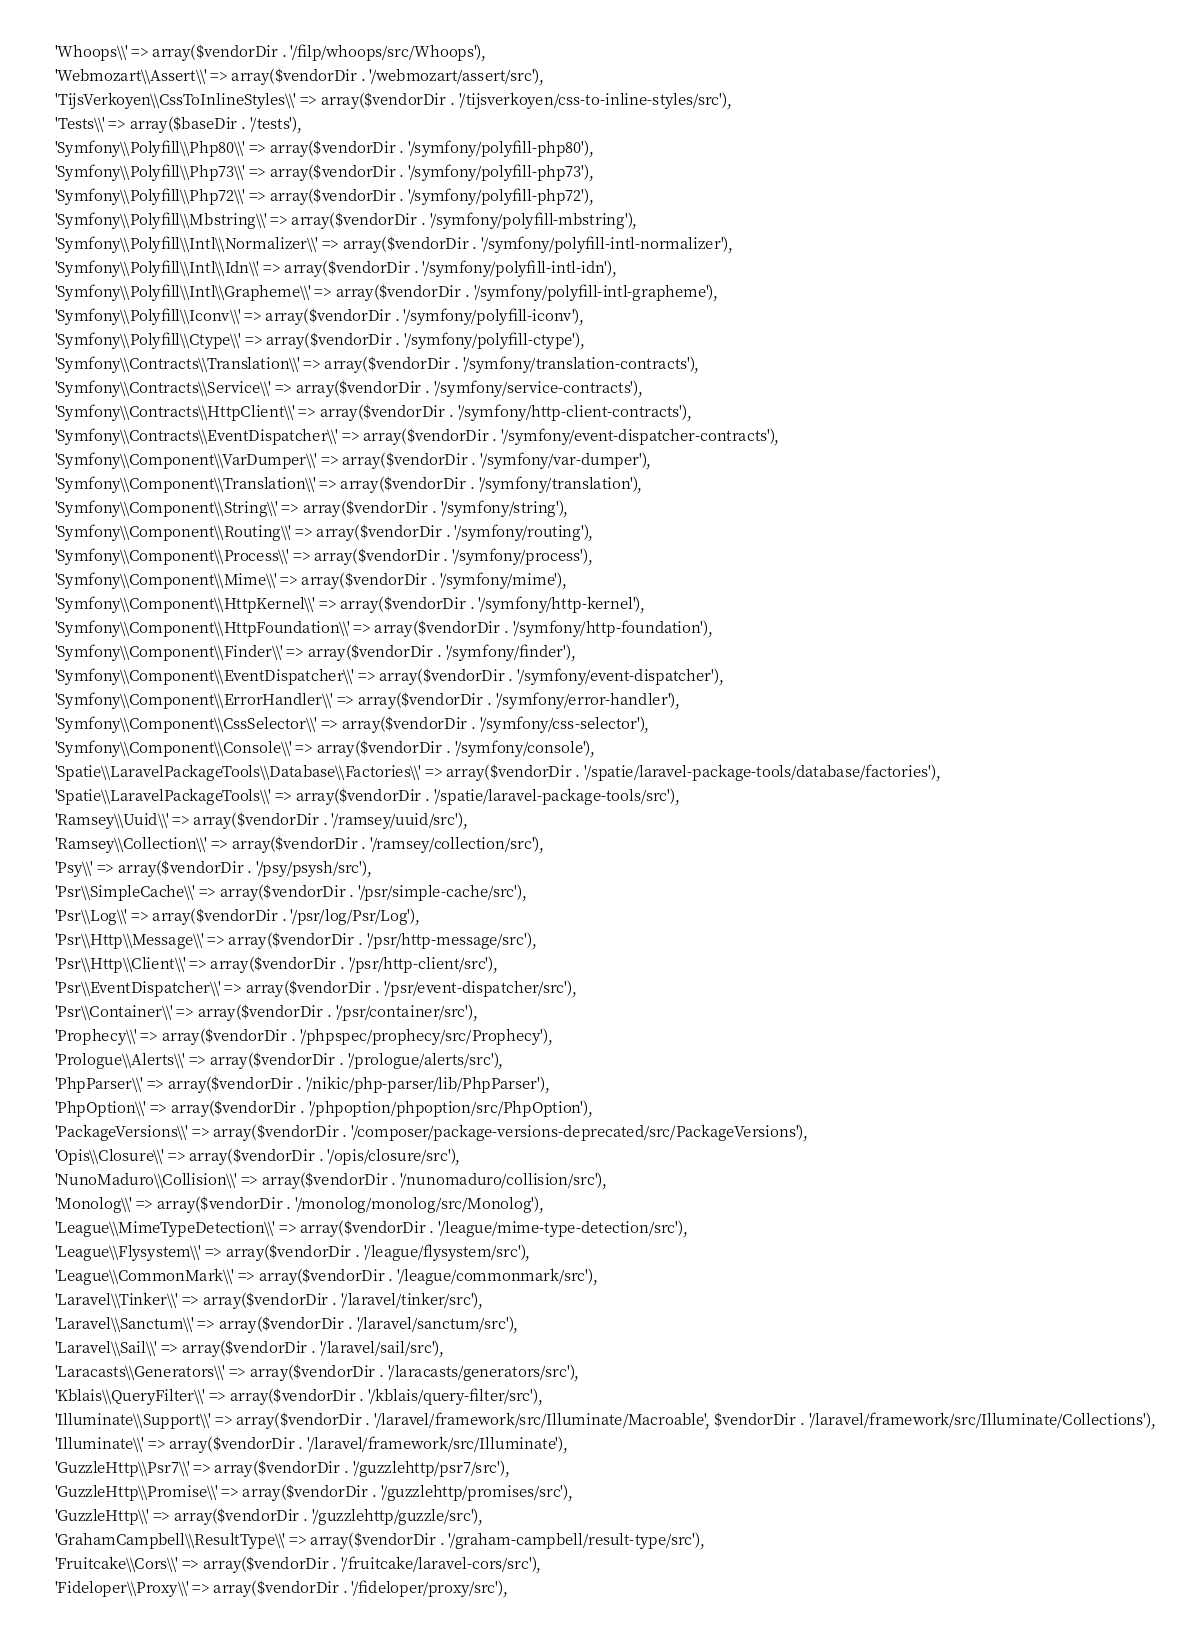<code> <loc_0><loc_0><loc_500><loc_500><_PHP_>    'Whoops\\' => array($vendorDir . '/filp/whoops/src/Whoops'),
    'Webmozart\\Assert\\' => array($vendorDir . '/webmozart/assert/src'),
    'TijsVerkoyen\\CssToInlineStyles\\' => array($vendorDir . '/tijsverkoyen/css-to-inline-styles/src'),
    'Tests\\' => array($baseDir . '/tests'),
    'Symfony\\Polyfill\\Php80\\' => array($vendorDir . '/symfony/polyfill-php80'),
    'Symfony\\Polyfill\\Php73\\' => array($vendorDir . '/symfony/polyfill-php73'),
    'Symfony\\Polyfill\\Php72\\' => array($vendorDir . '/symfony/polyfill-php72'),
    'Symfony\\Polyfill\\Mbstring\\' => array($vendorDir . '/symfony/polyfill-mbstring'),
    'Symfony\\Polyfill\\Intl\\Normalizer\\' => array($vendorDir . '/symfony/polyfill-intl-normalizer'),
    'Symfony\\Polyfill\\Intl\\Idn\\' => array($vendorDir . '/symfony/polyfill-intl-idn'),
    'Symfony\\Polyfill\\Intl\\Grapheme\\' => array($vendorDir . '/symfony/polyfill-intl-grapheme'),
    'Symfony\\Polyfill\\Iconv\\' => array($vendorDir . '/symfony/polyfill-iconv'),
    'Symfony\\Polyfill\\Ctype\\' => array($vendorDir . '/symfony/polyfill-ctype'),
    'Symfony\\Contracts\\Translation\\' => array($vendorDir . '/symfony/translation-contracts'),
    'Symfony\\Contracts\\Service\\' => array($vendorDir . '/symfony/service-contracts'),
    'Symfony\\Contracts\\HttpClient\\' => array($vendorDir . '/symfony/http-client-contracts'),
    'Symfony\\Contracts\\EventDispatcher\\' => array($vendorDir . '/symfony/event-dispatcher-contracts'),
    'Symfony\\Component\\VarDumper\\' => array($vendorDir . '/symfony/var-dumper'),
    'Symfony\\Component\\Translation\\' => array($vendorDir . '/symfony/translation'),
    'Symfony\\Component\\String\\' => array($vendorDir . '/symfony/string'),
    'Symfony\\Component\\Routing\\' => array($vendorDir . '/symfony/routing'),
    'Symfony\\Component\\Process\\' => array($vendorDir . '/symfony/process'),
    'Symfony\\Component\\Mime\\' => array($vendorDir . '/symfony/mime'),
    'Symfony\\Component\\HttpKernel\\' => array($vendorDir . '/symfony/http-kernel'),
    'Symfony\\Component\\HttpFoundation\\' => array($vendorDir . '/symfony/http-foundation'),
    'Symfony\\Component\\Finder\\' => array($vendorDir . '/symfony/finder'),
    'Symfony\\Component\\EventDispatcher\\' => array($vendorDir . '/symfony/event-dispatcher'),
    'Symfony\\Component\\ErrorHandler\\' => array($vendorDir . '/symfony/error-handler'),
    'Symfony\\Component\\CssSelector\\' => array($vendorDir . '/symfony/css-selector'),
    'Symfony\\Component\\Console\\' => array($vendorDir . '/symfony/console'),
    'Spatie\\LaravelPackageTools\\Database\\Factories\\' => array($vendorDir . '/spatie/laravel-package-tools/database/factories'),
    'Spatie\\LaravelPackageTools\\' => array($vendorDir . '/spatie/laravel-package-tools/src'),
    'Ramsey\\Uuid\\' => array($vendorDir . '/ramsey/uuid/src'),
    'Ramsey\\Collection\\' => array($vendorDir . '/ramsey/collection/src'),
    'Psy\\' => array($vendorDir . '/psy/psysh/src'),
    'Psr\\SimpleCache\\' => array($vendorDir . '/psr/simple-cache/src'),
    'Psr\\Log\\' => array($vendorDir . '/psr/log/Psr/Log'),
    'Psr\\Http\\Message\\' => array($vendorDir . '/psr/http-message/src'),
    'Psr\\Http\\Client\\' => array($vendorDir . '/psr/http-client/src'),
    'Psr\\EventDispatcher\\' => array($vendorDir . '/psr/event-dispatcher/src'),
    'Psr\\Container\\' => array($vendorDir . '/psr/container/src'),
    'Prophecy\\' => array($vendorDir . '/phpspec/prophecy/src/Prophecy'),
    'Prologue\\Alerts\\' => array($vendorDir . '/prologue/alerts/src'),
    'PhpParser\\' => array($vendorDir . '/nikic/php-parser/lib/PhpParser'),
    'PhpOption\\' => array($vendorDir . '/phpoption/phpoption/src/PhpOption'),
    'PackageVersions\\' => array($vendorDir . '/composer/package-versions-deprecated/src/PackageVersions'),
    'Opis\\Closure\\' => array($vendorDir . '/opis/closure/src'),
    'NunoMaduro\\Collision\\' => array($vendorDir . '/nunomaduro/collision/src'),
    'Monolog\\' => array($vendorDir . '/monolog/monolog/src/Monolog'),
    'League\\MimeTypeDetection\\' => array($vendorDir . '/league/mime-type-detection/src'),
    'League\\Flysystem\\' => array($vendorDir . '/league/flysystem/src'),
    'League\\CommonMark\\' => array($vendorDir . '/league/commonmark/src'),
    'Laravel\\Tinker\\' => array($vendorDir . '/laravel/tinker/src'),
    'Laravel\\Sanctum\\' => array($vendorDir . '/laravel/sanctum/src'),
    'Laravel\\Sail\\' => array($vendorDir . '/laravel/sail/src'),
    'Laracasts\\Generators\\' => array($vendorDir . '/laracasts/generators/src'),
    'Kblais\\QueryFilter\\' => array($vendorDir . '/kblais/query-filter/src'),
    'Illuminate\\Support\\' => array($vendorDir . '/laravel/framework/src/Illuminate/Macroable', $vendorDir . '/laravel/framework/src/Illuminate/Collections'),
    'Illuminate\\' => array($vendorDir . '/laravel/framework/src/Illuminate'),
    'GuzzleHttp\\Psr7\\' => array($vendorDir . '/guzzlehttp/psr7/src'),
    'GuzzleHttp\\Promise\\' => array($vendorDir . '/guzzlehttp/promises/src'),
    'GuzzleHttp\\' => array($vendorDir . '/guzzlehttp/guzzle/src'),
    'GrahamCampbell\\ResultType\\' => array($vendorDir . '/graham-campbell/result-type/src'),
    'Fruitcake\\Cors\\' => array($vendorDir . '/fruitcake/laravel-cors/src'),
    'Fideloper\\Proxy\\' => array($vendorDir . '/fideloper/proxy/src'),</code> 